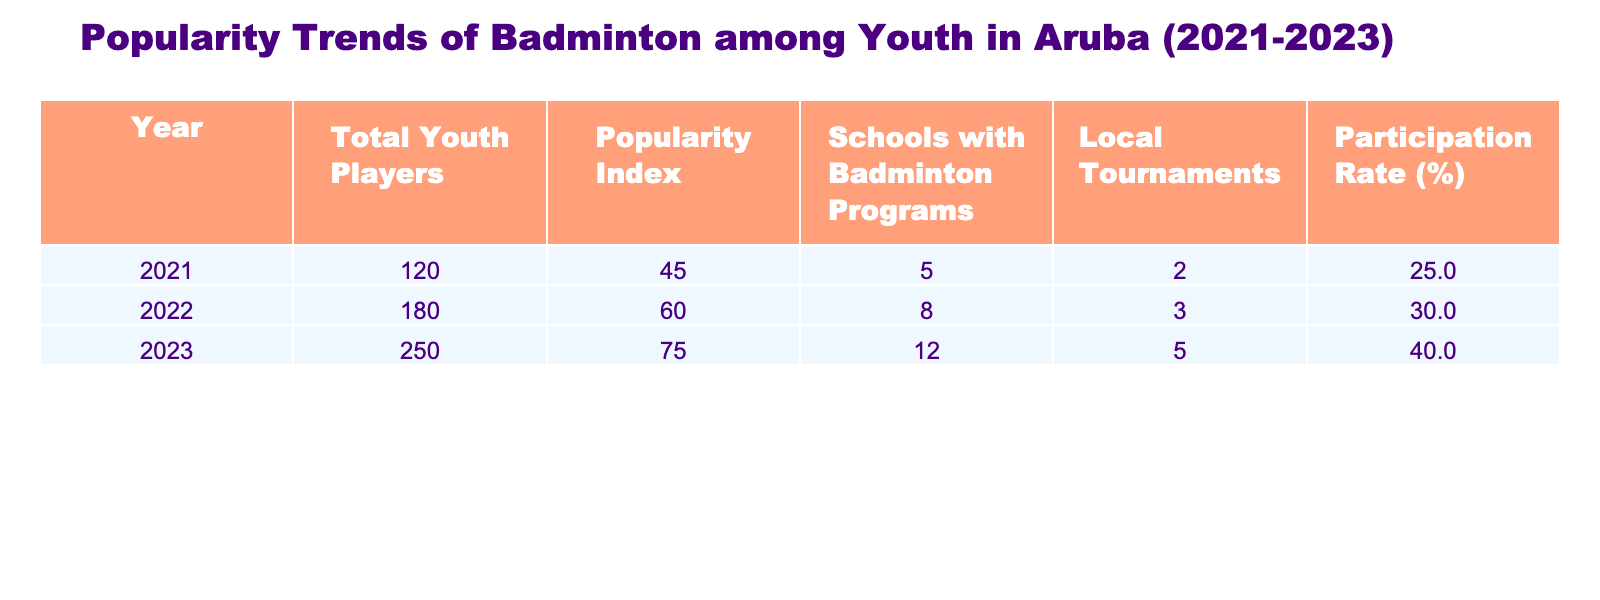What was the total number of youth players in 2022? Referring to the table, the value under "Total Youth Players" for the year 2022 is 180.
Answer: 180 What was the popularity index in 2023? Looking at the "Popularity Index" column for the year 2023, the value is 75.
Answer: 75 How many schools had badminton programs in 2021 compared to 2023? The table shows 5 schools in 2021 and 12 schools in 2023, which means there were 7 more schools in 2023.
Answer: There were 7 more schools What was the participation rate in 2021? The table lists the participation rate for 2021 as 25%.
Answer: 25% What is the average popularity index over the three years? To find the average, sum the popularity indexes: 45 + 60 + 75 = 180. Divide by 3, resulting in 180/3 = 60.
Answer: 60 Did the total number of local tournaments increase from 2021 to 2023? Comparing the values, the number of local tournaments increased from 2 in 2021 to 5 in 2023. Therefore, the statement is true.
Answer: Yes In which year was the participation rate highest, and what was that rate? By examining the participation rates, 2023 has the highest rate of 40%, compared to 25% in 2021 and 30% in 2022.
Answer: 2023, 40% How many more local tournaments were held in 2023 compared to 2021? The table indicates 5 local tournaments in 2023 and 2 in 2021. Subtracting gives: 5 - 2 = 3 additional tournaments.
Answer: 3 more tournaments What was the total increase in youth players from 2021 to 2023? The total youth players in 2021 were 120, and in 2023 it was 250. The increase is 250 - 120 = 130.
Answer: 130 Was the increase in the number of schools with badminton programs from 2021 to 2023 greater than the increase in the number of local tournaments? The increase in schools was from 5 in 2021 to 12 in 2023 (7 more). The increase in local tournaments was from 2 to 5 (3 more). Since 7 is greater than 3, the answer is yes.
Answer: Yes 